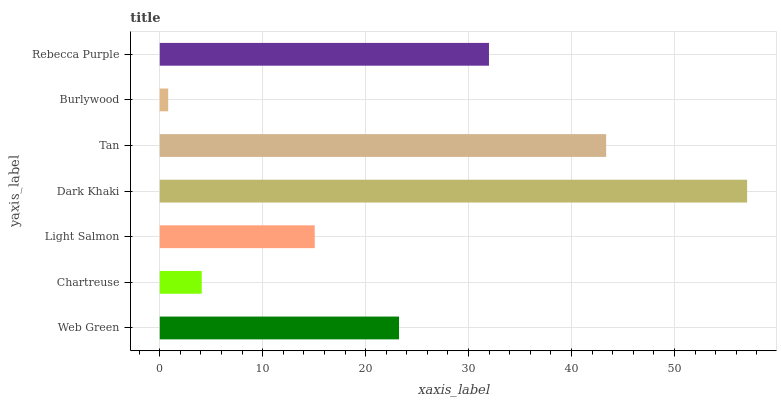Is Burlywood the minimum?
Answer yes or no. Yes. Is Dark Khaki the maximum?
Answer yes or no. Yes. Is Chartreuse the minimum?
Answer yes or no. No. Is Chartreuse the maximum?
Answer yes or no. No. Is Web Green greater than Chartreuse?
Answer yes or no. Yes. Is Chartreuse less than Web Green?
Answer yes or no. Yes. Is Chartreuse greater than Web Green?
Answer yes or no. No. Is Web Green less than Chartreuse?
Answer yes or no. No. Is Web Green the high median?
Answer yes or no. Yes. Is Web Green the low median?
Answer yes or no. Yes. Is Dark Khaki the high median?
Answer yes or no. No. Is Chartreuse the low median?
Answer yes or no. No. 